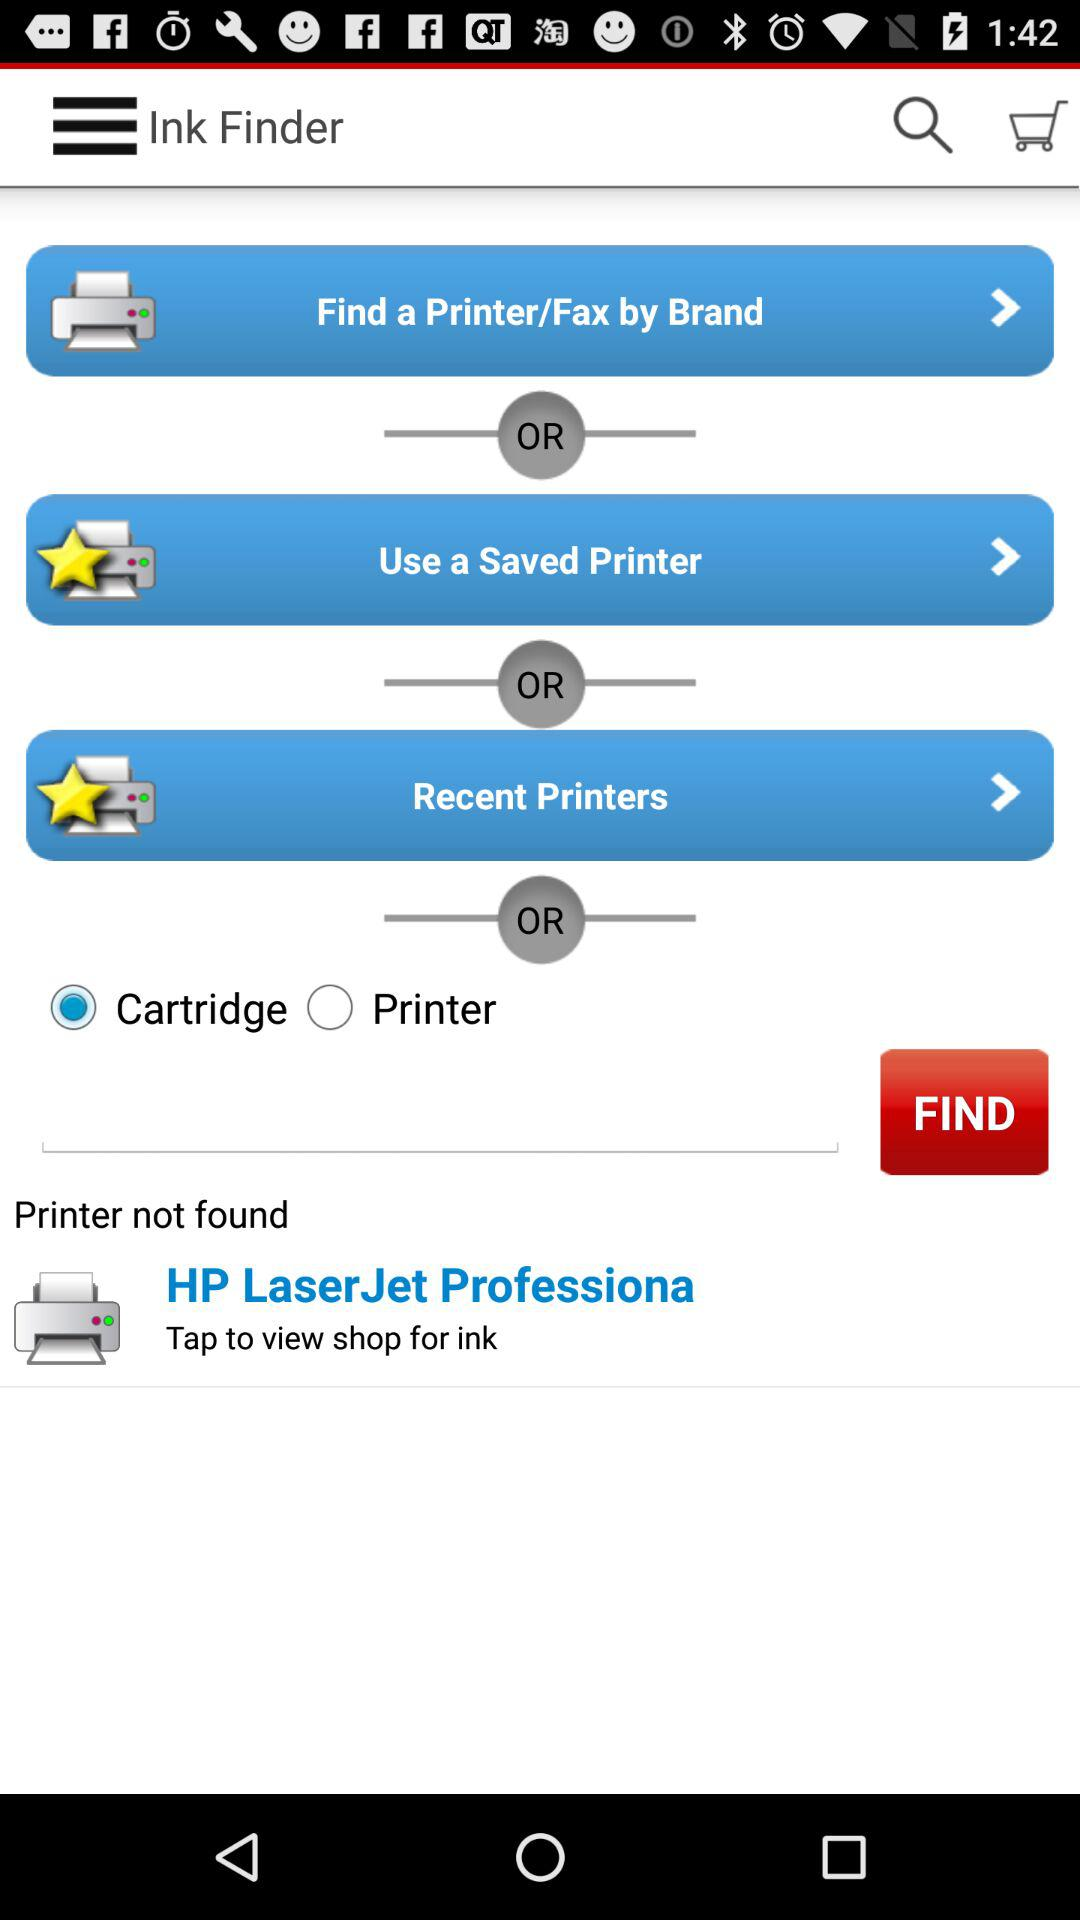Which ink does the printer use?
When the provided information is insufficient, respond with <no answer>. <no answer> 